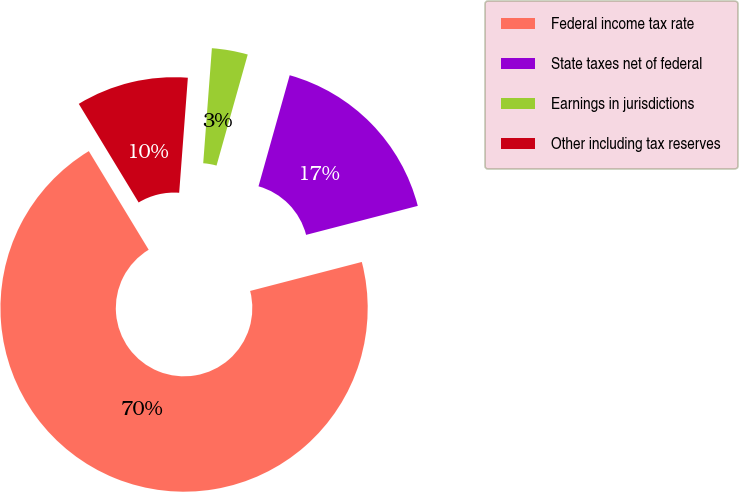Convert chart. <chart><loc_0><loc_0><loc_500><loc_500><pie_chart><fcel>Federal income tax rate<fcel>State taxes net of federal<fcel>Earnings in jurisdictions<fcel>Other including tax reserves<nl><fcel>70.36%<fcel>16.6%<fcel>3.16%<fcel>9.88%<nl></chart> 